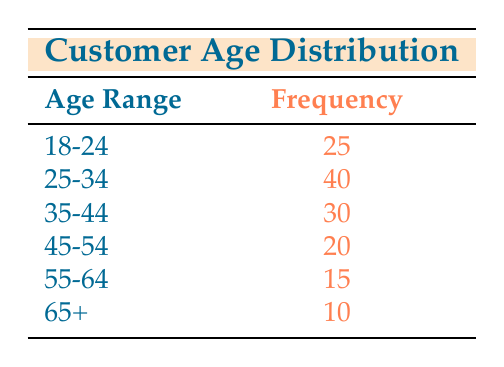What is the frequency of customers in the age range 25-34? The table lists the frequency of customers for each age range, and the frequency for the age range 25-34 is shown as 40.
Answer: 40 How many customers are in the age range 18-24 and 35-44 combined? To find the total frequency for the age ranges 18-24 and 35-44, add their frequencies: 25 (18-24) + 30 (35-44) = 55.
Answer: 55 Is the frequency of customers aged 45-54 greater than that of those aged 55-64? The frequency for the age range 45-54 is 20, and for 55-64 it is 15. Since 20 is greater than 15, the answer is yes.
Answer: Yes What is the total frequency of customers aged 25 and above? To get the total frequency of customers aged 25 and above, add the frequencies for the age ranges 25-34, 35-44, 45-54, 55-64, and 65+: 40 + 30 + 20 + 15 + 10 = 115.
Answer: 115 What percentage of customers belong to the age group 65 and older? The total number of customers is found by summing up all frequencies: 25 + 40 + 30 + 20 + 15 + 10 = 140. The frequency for the age group 65+ is 10. To find the percentage, calculate (10 / 140) * 100 = 7.14%.
Answer: 7.14% Which age group has the highest frequency, and what is that frequency? By examining the table, the age group with the highest frequency is 25-34, which has a frequency of 40.
Answer: 25-34, 40 How does the frequency of the 55-64 age group compare to the frequency of the 18-24 age group? The frequency of the 55-64 age group is 15, while the frequency for the 18-24 age group is 25. Since 25 is greater than 15, the 18-24 age group has a higher frequency.
Answer: 18-24 has a higher frequency What is the average frequency across all age groups? To find the average frequency, first sum all the frequencies: 25 + 40 + 30 + 20 + 15 + 10 = 140. There are 6 age groups, so the average is 140 / 6 ≈ 23.33.
Answer: 23.33 Is it true that more than half of the customers are between the ages of 25 and 34? The frequency for the age group 25-34 is 40, and the total number of customers is 140. Since 40 is not more than half of 140 (which is 70), the answer is no.
Answer: No 